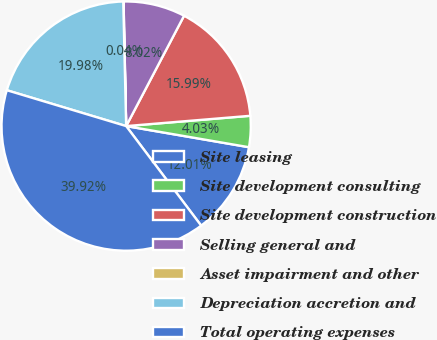Convert chart to OTSL. <chart><loc_0><loc_0><loc_500><loc_500><pie_chart><fcel>Site leasing<fcel>Site development consulting<fcel>Site development construction<fcel>Selling general and<fcel>Asset impairment and other<fcel>Depreciation accretion and<fcel>Total operating expenses<nl><fcel>12.01%<fcel>4.03%<fcel>15.99%<fcel>8.02%<fcel>0.04%<fcel>19.98%<fcel>39.92%<nl></chart> 